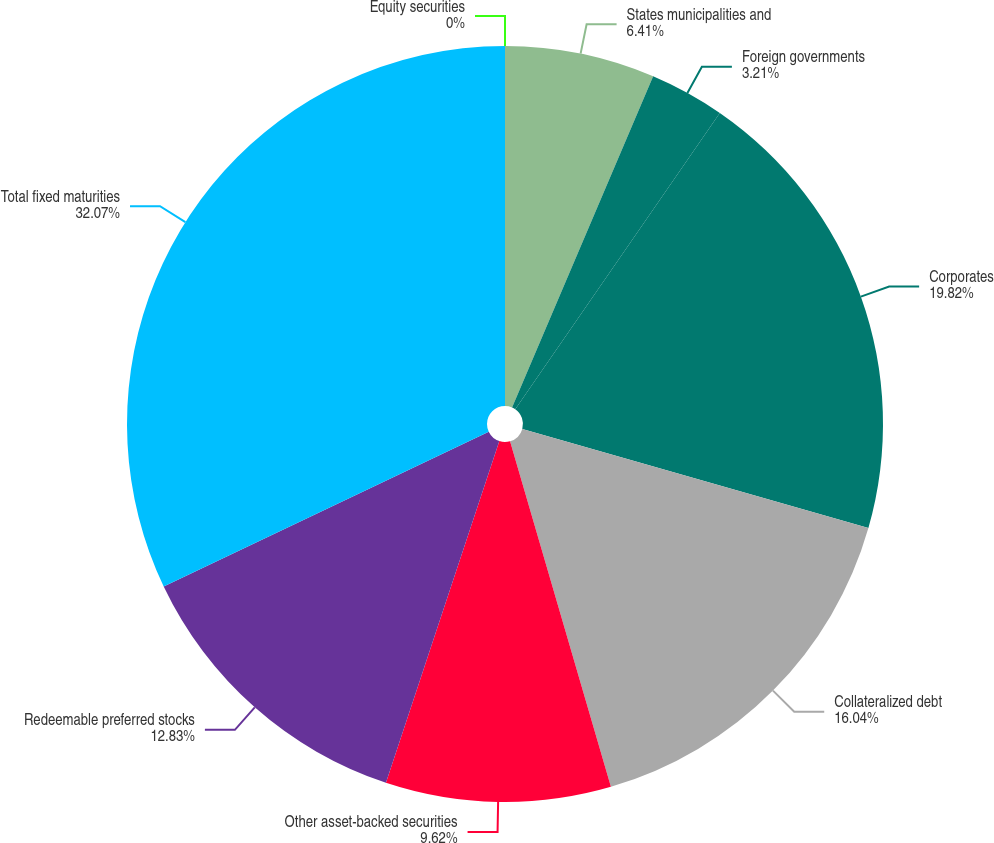Convert chart to OTSL. <chart><loc_0><loc_0><loc_500><loc_500><pie_chart><fcel>States municipalities and<fcel>Foreign governments<fcel>Corporates<fcel>Collateralized debt<fcel>Other asset-backed securities<fcel>Redeemable preferred stocks<fcel>Total fixed maturities<fcel>Equity securities<nl><fcel>6.41%<fcel>3.21%<fcel>19.82%<fcel>16.04%<fcel>9.62%<fcel>12.83%<fcel>32.07%<fcel>0.0%<nl></chart> 